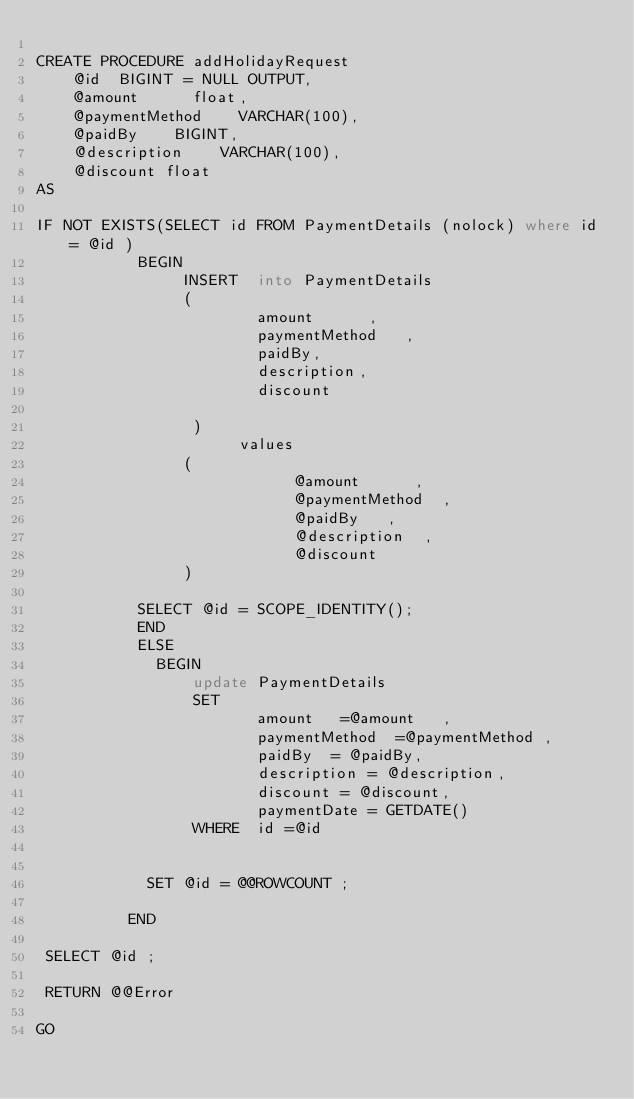Convert code to text. <code><loc_0><loc_0><loc_500><loc_500><_SQL_>
CREATE PROCEDURE addHolidayRequest
    @id  BIGINT = NULL OUTPUT,
    @amount      float,
    @paymentMethod    VARCHAR(100),
    @paidBy    BIGINT,
    @description    VARCHAR(100),
    @discount float
AS

IF NOT EXISTS(SELECT id FROM PaymentDetails (nolock) where id = @id )
           BEGIN
                INSERT  into PaymentDetails
                (
                        amount      ,
                        paymentMethod   ,
                        paidBy,
                        description,
                        discount

                 )
                      values
                (
                            @amount      ,
                            @paymentMethod  ,
                            @paidBy   ,
                            @description  ,
                            @discount
                )

				   SELECT @id = SCOPE_IDENTITY();
           END
           ELSE
             BEGIN
                 update PaymentDetails
                 SET
                        amount   =@amount   ,
                        paymentMethod  =@paymentMethod ,
                        paidBy  = @paidBy,
                        description = @description,
                        discount = @discount,
                        paymentDate = GETDATE()
                 WHERE  id =@id


            SET @id = @@ROWCOUNT ;

          END

 SELECT @id ;

 RETURN @@Error

GO


</code> 